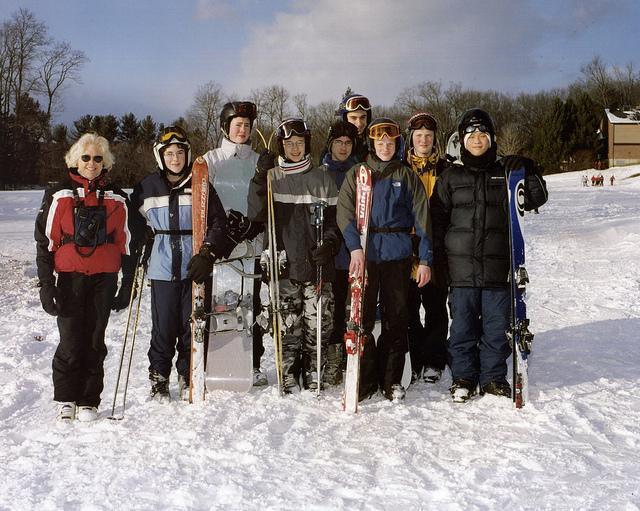How many ski can be seen?
Give a very brief answer. 2. How many people are in the photo?
Give a very brief answer. 8. How many surfboards are in the picture?
Give a very brief answer. 0. 